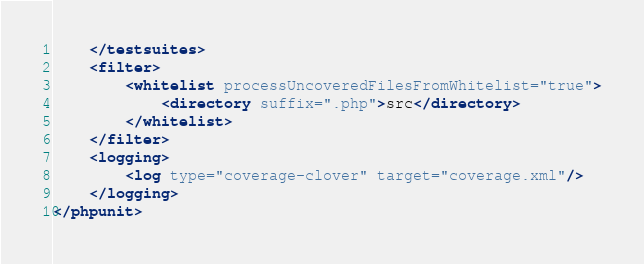<code> <loc_0><loc_0><loc_500><loc_500><_XML_>    </testsuites>
    <filter>
        <whitelist processUncoveredFilesFromWhitelist="true">
            <directory suffix=".php">src</directory>
        </whitelist>
    </filter>
    <logging>
        <log type="coverage-clover" target="coverage.xml"/>
    </logging>
</phpunit>
</code> 